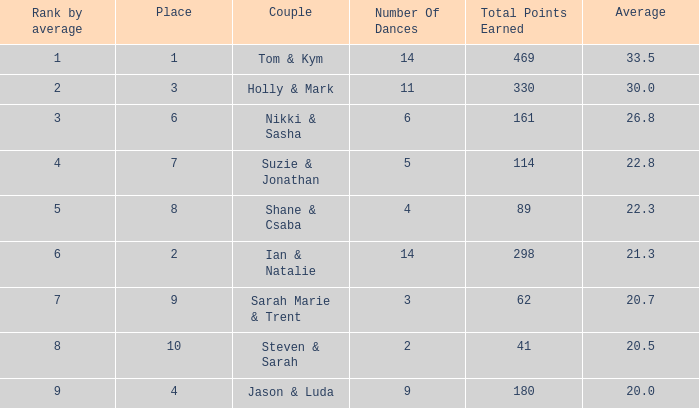What is the number of dances total number if the average is 22.3? 1.0. 